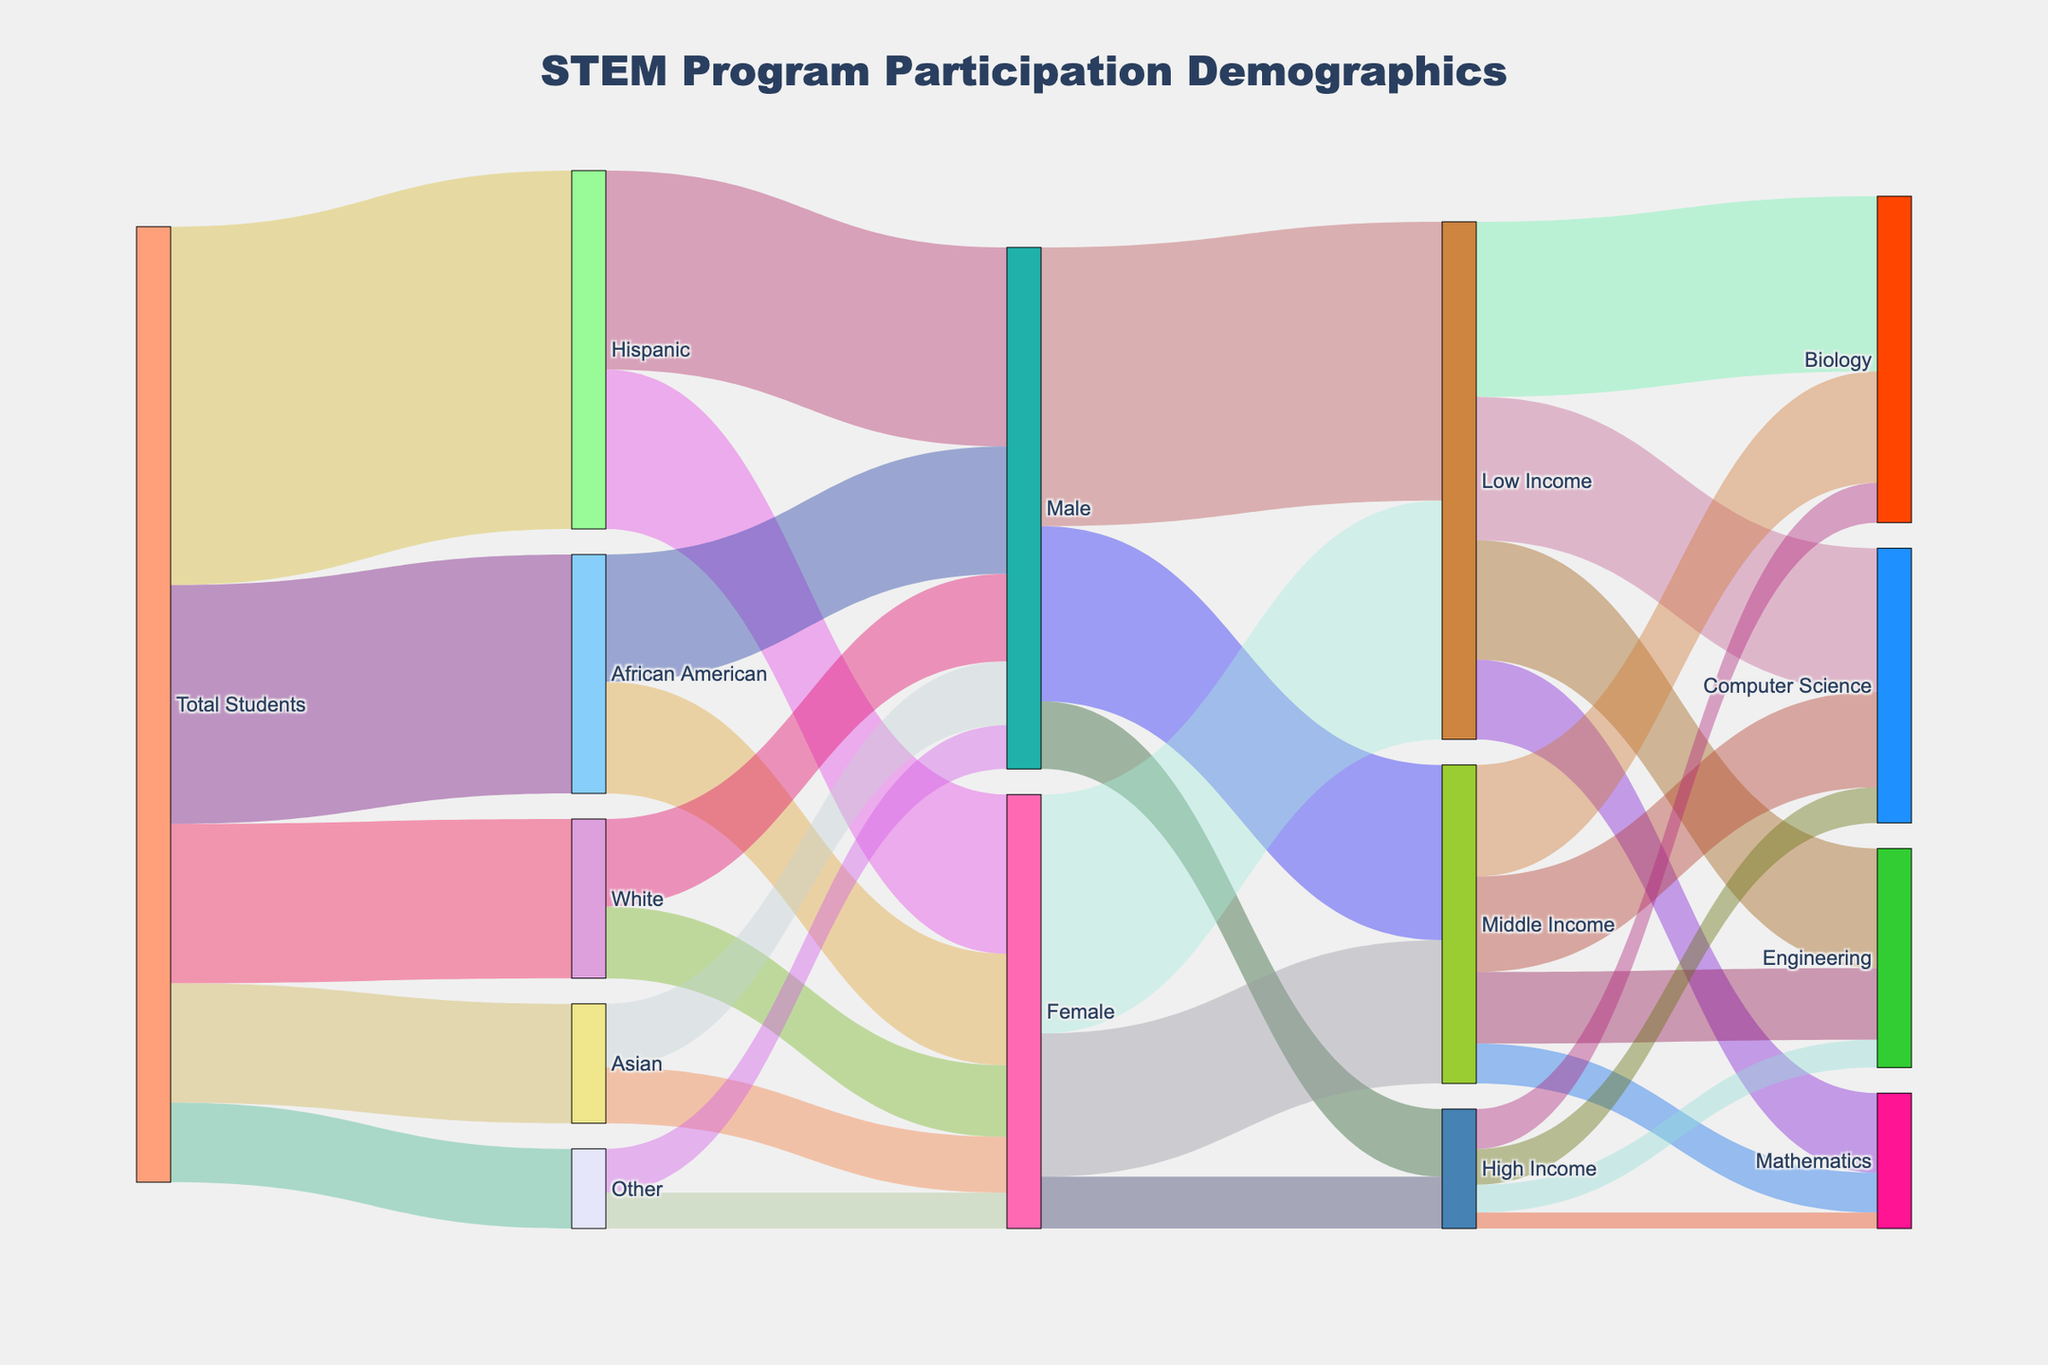what is the total number of Hispanic students participating in the STEM program? According to the Sankey diagram, Hispanic students are part of the total student flow, and the corresponding value is provided as 450.
Answer: 450 Between male Hispanic students and female Hispanic students, which group is larger? The Sankey diagram shows that there are 250 male Hispanic students and 200 female Hispanic students. Comparing these values, male Hispanic students are the larger group.
Answer: Male Hispanic students How many high-income female students are there? By tracing the flow from 'Female' to 'High Income' in the Sankey diagram, we see the value is given as 65.
Answer: 65 Are there more low-income or high-income students in the Computer Science program? The values for each income group in Computer Science can be found by tracing the corresponding flows: Low Income (180) and High Income (45). Comparing these values, there are more low-income students.
Answer: Low-income students What is the shared total number of African American male and female students in the STEM program? The Sankey diagram indicates there are 160 African American male students and 140 African American female students. Summing these two values gives 160 + 140 = 300.
Answer: 300 Which program has the highest participation from low-income students? By following the flows from 'Low Income' to various programs, Biology has 220 students, Computer Science has 180, Engineering has 150, and Mathematics has 100. The highest value is 220 for Biology.
Answer: Biology How does the number of Asian students compare to the number of students classified as 'Other'? The diagram shows 150 Asian students and 100 students classified as 'Other'. Asian students outnumber students classified as 'Other'.
Answer: Asian students How many more male students are participating in STEM programs compared to female students? By tracing the gender breakdown from the total students, male students total 250 (Hispanic) + 160 (African American) + 110 (White) + 80 (Asian) + 55 (Other) = 655. Female students total 200 (Hispanic) + 140 (African American) + 90 (White) + 70 (Asian) + 45 (Other) = 545. The difference is 655 - 545 = 110.
Answer: 110 What is the total number of students in Middle Income groups across both genders? From the diagram, the number of Middle Income students among males is 220, and among females is 180. Adding these values gives 220 + 180 = 400.
Answer: 400 